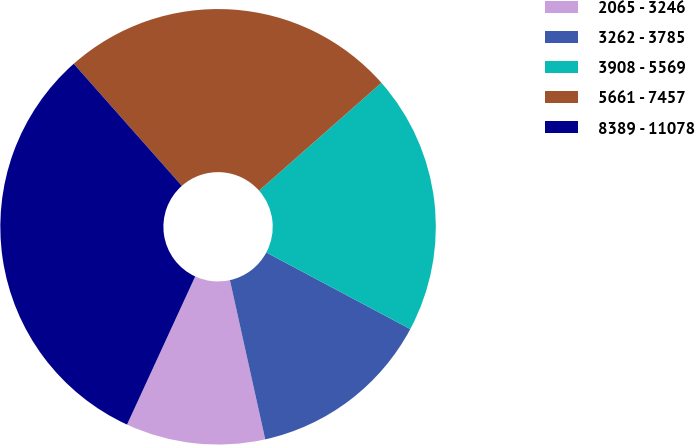Convert chart to OTSL. <chart><loc_0><loc_0><loc_500><loc_500><pie_chart><fcel>2065 - 3246<fcel>3262 - 3785<fcel>3908 - 5569<fcel>5661 - 7457<fcel>8389 - 11078<nl><fcel>10.34%<fcel>13.74%<fcel>19.28%<fcel>25.03%<fcel>31.6%<nl></chart> 